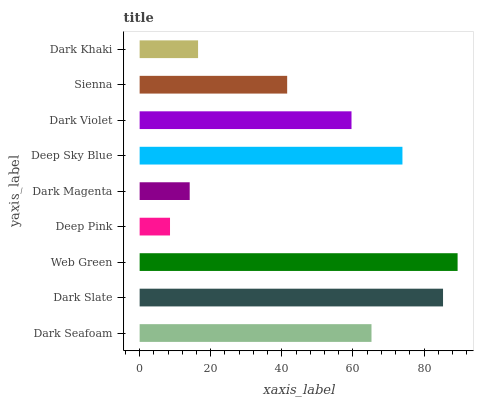Is Deep Pink the minimum?
Answer yes or no. Yes. Is Web Green the maximum?
Answer yes or no. Yes. Is Dark Slate the minimum?
Answer yes or no. No. Is Dark Slate the maximum?
Answer yes or no. No. Is Dark Slate greater than Dark Seafoam?
Answer yes or no. Yes. Is Dark Seafoam less than Dark Slate?
Answer yes or no. Yes. Is Dark Seafoam greater than Dark Slate?
Answer yes or no. No. Is Dark Slate less than Dark Seafoam?
Answer yes or no. No. Is Dark Violet the high median?
Answer yes or no. Yes. Is Dark Violet the low median?
Answer yes or no. Yes. Is Deep Pink the high median?
Answer yes or no. No. Is Deep Sky Blue the low median?
Answer yes or no. No. 